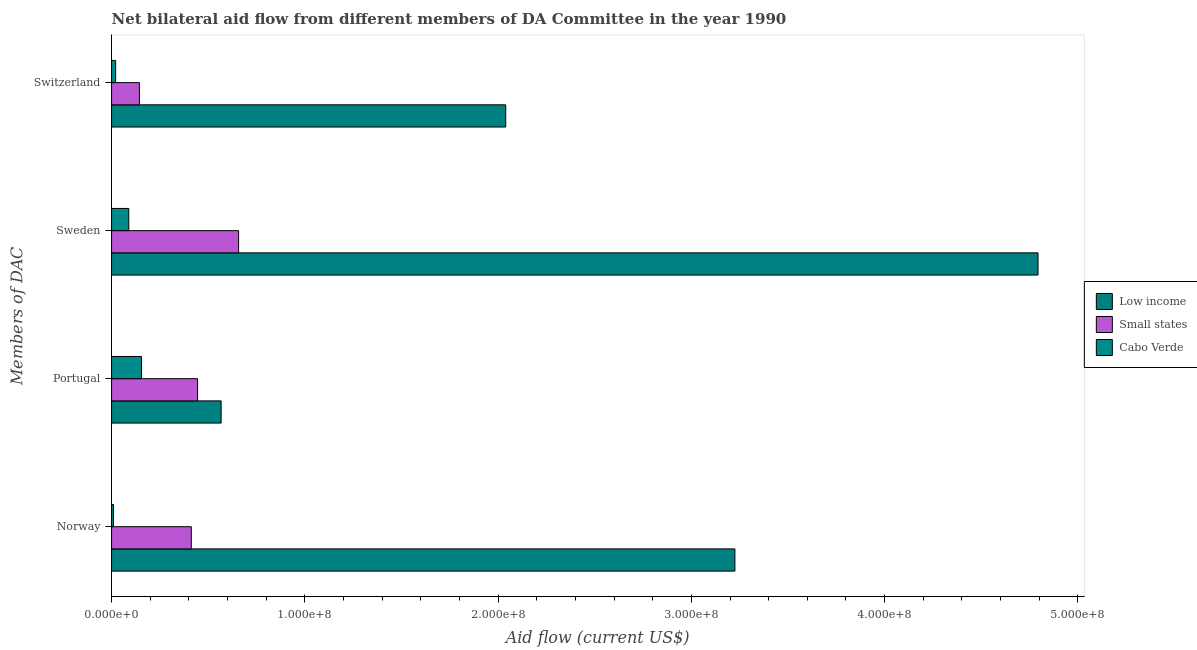Are the number of bars per tick equal to the number of legend labels?
Give a very brief answer. Yes. How many bars are there on the 1st tick from the top?
Keep it short and to the point. 3. How many bars are there on the 2nd tick from the bottom?
Ensure brevity in your answer.  3. What is the label of the 3rd group of bars from the top?
Your answer should be very brief. Portugal. What is the amount of aid given by norway in Low income?
Ensure brevity in your answer.  3.23e+08. Across all countries, what is the maximum amount of aid given by portugal?
Provide a short and direct response. 5.67e+07. Across all countries, what is the minimum amount of aid given by switzerland?
Offer a terse response. 2.11e+06. In which country was the amount of aid given by portugal maximum?
Offer a terse response. Low income. In which country was the amount of aid given by sweden minimum?
Your answer should be very brief. Cabo Verde. What is the total amount of aid given by portugal in the graph?
Offer a terse response. 1.17e+08. What is the difference between the amount of aid given by switzerland in Cabo Verde and that in Small states?
Keep it short and to the point. -1.23e+07. What is the difference between the amount of aid given by sweden in Low income and the amount of aid given by norway in Cabo Verde?
Your response must be concise. 4.78e+08. What is the average amount of aid given by norway per country?
Ensure brevity in your answer.  1.22e+08. What is the difference between the amount of aid given by portugal and amount of aid given by sweden in Low income?
Your answer should be compact. -4.23e+08. In how many countries, is the amount of aid given by norway greater than 140000000 US$?
Your answer should be very brief. 1. What is the ratio of the amount of aid given by switzerland in Cabo Verde to that in Low income?
Offer a very short reply. 0.01. Is the amount of aid given by switzerland in Low income less than that in Small states?
Your response must be concise. No. What is the difference between the highest and the second highest amount of aid given by norway?
Your answer should be compact. 2.81e+08. What is the difference between the highest and the lowest amount of aid given by switzerland?
Keep it short and to the point. 2.02e+08. In how many countries, is the amount of aid given by norway greater than the average amount of aid given by norway taken over all countries?
Provide a short and direct response. 1. Is the sum of the amount of aid given by sweden in Small states and Low income greater than the maximum amount of aid given by portugal across all countries?
Your response must be concise. Yes. Is it the case that in every country, the sum of the amount of aid given by portugal and amount of aid given by sweden is greater than the sum of amount of aid given by norway and amount of aid given by switzerland?
Offer a very short reply. No. What does the 1st bar from the top in Portugal represents?
Your answer should be compact. Cabo Verde. What does the 3rd bar from the bottom in Portugal represents?
Your answer should be compact. Cabo Verde. Is it the case that in every country, the sum of the amount of aid given by norway and amount of aid given by portugal is greater than the amount of aid given by sweden?
Offer a terse response. No. Are all the bars in the graph horizontal?
Offer a terse response. Yes. Does the graph contain any zero values?
Provide a short and direct response. No. Does the graph contain grids?
Give a very brief answer. No. How many legend labels are there?
Your answer should be compact. 3. How are the legend labels stacked?
Make the answer very short. Vertical. What is the title of the graph?
Offer a very short reply. Net bilateral aid flow from different members of DA Committee in the year 1990. What is the label or title of the X-axis?
Keep it short and to the point. Aid flow (current US$). What is the label or title of the Y-axis?
Your response must be concise. Members of DAC. What is the Aid flow (current US$) of Low income in Norway?
Keep it short and to the point. 3.23e+08. What is the Aid flow (current US$) of Small states in Norway?
Your answer should be compact. 4.13e+07. What is the Aid flow (current US$) in Cabo Verde in Norway?
Provide a succinct answer. 9.80e+05. What is the Aid flow (current US$) in Low income in Portugal?
Keep it short and to the point. 5.67e+07. What is the Aid flow (current US$) in Small states in Portugal?
Your response must be concise. 4.45e+07. What is the Aid flow (current US$) in Cabo Verde in Portugal?
Offer a very short reply. 1.55e+07. What is the Aid flow (current US$) in Low income in Sweden?
Ensure brevity in your answer.  4.79e+08. What is the Aid flow (current US$) of Small states in Sweden?
Keep it short and to the point. 6.57e+07. What is the Aid flow (current US$) of Cabo Verde in Sweden?
Offer a very short reply. 8.91e+06. What is the Aid flow (current US$) in Low income in Switzerland?
Make the answer very short. 2.04e+08. What is the Aid flow (current US$) in Small states in Switzerland?
Give a very brief answer. 1.44e+07. What is the Aid flow (current US$) of Cabo Verde in Switzerland?
Ensure brevity in your answer.  2.11e+06. Across all Members of DAC, what is the maximum Aid flow (current US$) in Low income?
Provide a succinct answer. 4.79e+08. Across all Members of DAC, what is the maximum Aid flow (current US$) in Small states?
Your response must be concise. 6.57e+07. Across all Members of DAC, what is the maximum Aid flow (current US$) in Cabo Verde?
Your answer should be very brief. 1.55e+07. Across all Members of DAC, what is the minimum Aid flow (current US$) of Low income?
Offer a very short reply. 5.67e+07. Across all Members of DAC, what is the minimum Aid flow (current US$) in Small states?
Keep it short and to the point. 1.44e+07. Across all Members of DAC, what is the minimum Aid flow (current US$) in Cabo Verde?
Your answer should be compact. 9.80e+05. What is the total Aid flow (current US$) in Low income in the graph?
Your answer should be compact. 1.06e+09. What is the total Aid flow (current US$) in Small states in the graph?
Make the answer very short. 1.66e+08. What is the total Aid flow (current US$) of Cabo Verde in the graph?
Your answer should be very brief. 2.75e+07. What is the difference between the Aid flow (current US$) of Low income in Norway and that in Portugal?
Your answer should be very brief. 2.66e+08. What is the difference between the Aid flow (current US$) of Small states in Norway and that in Portugal?
Offer a very short reply. -3.24e+06. What is the difference between the Aid flow (current US$) in Cabo Verde in Norway and that in Portugal?
Offer a terse response. -1.45e+07. What is the difference between the Aid flow (current US$) in Low income in Norway and that in Sweden?
Provide a short and direct response. -1.57e+08. What is the difference between the Aid flow (current US$) of Small states in Norway and that in Sweden?
Give a very brief answer. -2.45e+07. What is the difference between the Aid flow (current US$) in Cabo Verde in Norway and that in Sweden?
Give a very brief answer. -7.93e+06. What is the difference between the Aid flow (current US$) of Low income in Norway and that in Switzerland?
Provide a short and direct response. 1.19e+08. What is the difference between the Aid flow (current US$) of Small states in Norway and that in Switzerland?
Provide a succinct answer. 2.69e+07. What is the difference between the Aid flow (current US$) of Cabo Verde in Norway and that in Switzerland?
Keep it short and to the point. -1.13e+06. What is the difference between the Aid flow (current US$) in Low income in Portugal and that in Sweden?
Your answer should be compact. -4.23e+08. What is the difference between the Aid flow (current US$) of Small states in Portugal and that in Sweden?
Provide a short and direct response. -2.12e+07. What is the difference between the Aid flow (current US$) of Cabo Verde in Portugal and that in Sweden?
Provide a succinct answer. 6.59e+06. What is the difference between the Aid flow (current US$) of Low income in Portugal and that in Switzerland?
Provide a short and direct response. -1.47e+08. What is the difference between the Aid flow (current US$) in Small states in Portugal and that in Switzerland?
Offer a very short reply. 3.01e+07. What is the difference between the Aid flow (current US$) in Cabo Verde in Portugal and that in Switzerland?
Your answer should be compact. 1.34e+07. What is the difference between the Aid flow (current US$) in Low income in Sweden and that in Switzerland?
Offer a terse response. 2.75e+08. What is the difference between the Aid flow (current US$) in Small states in Sweden and that in Switzerland?
Give a very brief answer. 5.13e+07. What is the difference between the Aid flow (current US$) of Cabo Verde in Sweden and that in Switzerland?
Give a very brief answer. 6.80e+06. What is the difference between the Aid flow (current US$) of Low income in Norway and the Aid flow (current US$) of Small states in Portugal?
Offer a terse response. 2.78e+08. What is the difference between the Aid flow (current US$) in Low income in Norway and the Aid flow (current US$) in Cabo Verde in Portugal?
Make the answer very short. 3.07e+08. What is the difference between the Aid flow (current US$) in Small states in Norway and the Aid flow (current US$) in Cabo Verde in Portugal?
Your answer should be compact. 2.58e+07. What is the difference between the Aid flow (current US$) of Low income in Norway and the Aid flow (current US$) of Small states in Sweden?
Make the answer very short. 2.57e+08. What is the difference between the Aid flow (current US$) of Low income in Norway and the Aid flow (current US$) of Cabo Verde in Sweden?
Provide a succinct answer. 3.14e+08. What is the difference between the Aid flow (current US$) in Small states in Norway and the Aid flow (current US$) in Cabo Verde in Sweden?
Keep it short and to the point. 3.24e+07. What is the difference between the Aid flow (current US$) in Low income in Norway and the Aid flow (current US$) in Small states in Switzerland?
Make the answer very short. 3.08e+08. What is the difference between the Aid flow (current US$) of Low income in Norway and the Aid flow (current US$) of Cabo Verde in Switzerland?
Give a very brief answer. 3.20e+08. What is the difference between the Aid flow (current US$) of Small states in Norway and the Aid flow (current US$) of Cabo Verde in Switzerland?
Give a very brief answer. 3.92e+07. What is the difference between the Aid flow (current US$) of Low income in Portugal and the Aid flow (current US$) of Small states in Sweden?
Provide a succinct answer. -9.03e+06. What is the difference between the Aid flow (current US$) of Low income in Portugal and the Aid flow (current US$) of Cabo Verde in Sweden?
Offer a terse response. 4.78e+07. What is the difference between the Aid flow (current US$) in Small states in Portugal and the Aid flow (current US$) in Cabo Verde in Sweden?
Make the answer very short. 3.56e+07. What is the difference between the Aid flow (current US$) of Low income in Portugal and the Aid flow (current US$) of Small states in Switzerland?
Provide a short and direct response. 4.23e+07. What is the difference between the Aid flow (current US$) in Low income in Portugal and the Aid flow (current US$) in Cabo Verde in Switzerland?
Keep it short and to the point. 5.46e+07. What is the difference between the Aid flow (current US$) of Small states in Portugal and the Aid flow (current US$) of Cabo Verde in Switzerland?
Your response must be concise. 4.24e+07. What is the difference between the Aid flow (current US$) in Low income in Sweden and the Aid flow (current US$) in Small states in Switzerland?
Make the answer very short. 4.65e+08. What is the difference between the Aid flow (current US$) in Low income in Sweden and the Aid flow (current US$) in Cabo Verde in Switzerland?
Make the answer very short. 4.77e+08. What is the difference between the Aid flow (current US$) of Small states in Sweden and the Aid flow (current US$) of Cabo Verde in Switzerland?
Provide a short and direct response. 6.36e+07. What is the average Aid flow (current US$) in Low income per Members of DAC?
Your answer should be very brief. 2.66e+08. What is the average Aid flow (current US$) in Small states per Members of DAC?
Your answer should be very brief. 4.15e+07. What is the average Aid flow (current US$) of Cabo Verde per Members of DAC?
Provide a short and direct response. 6.88e+06. What is the difference between the Aid flow (current US$) in Low income and Aid flow (current US$) in Small states in Norway?
Ensure brevity in your answer.  2.81e+08. What is the difference between the Aid flow (current US$) in Low income and Aid flow (current US$) in Cabo Verde in Norway?
Your answer should be compact. 3.22e+08. What is the difference between the Aid flow (current US$) in Small states and Aid flow (current US$) in Cabo Verde in Norway?
Your answer should be compact. 4.03e+07. What is the difference between the Aid flow (current US$) of Low income and Aid flow (current US$) of Small states in Portugal?
Your answer should be very brief. 1.22e+07. What is the difference between the Aid flow (current US$) in Low income and Aid flow (current US$) in Cabo Verde in Portugal?
Offer a very short reply. 4.12e+07. What is the difference between the Aid flow (current US$) of Small states and Aid flow (current US$) of Cabo Verde in Portugal?
Your answer should be very brief. 2.90e+07. What is the difference between the Aid flow (current US$) of Low income and Aid flow (current US$) of Small states in Sweden?
Your answer should be compact. 4.14e+08. What is the difference between the Aid flow (current US$) of Low income and Aid flow (current US$) of Cabo Verde in Sweden?
Provide a succinct answer. 4.70e+08. What is the difference between the Aid flow (current US$) in Small states and Aid flow (current US$) in Cabo Verde in Sweden?
Provide a succinct answer. 5.68e+07. What is the difference between the Aid flow (current US$) of Low income and Aid flow (current US$) of Small states in Switzerland?
Offer a very short reply. 1.90e+08. What is the difference between the Aid flow (current US$) in Low income and Aid flow (current US$) in Cabo Verde in Switzerland?
Your answer should be compact. 2.02e+08. What is the difference between the Aid flow (current US$) in Small states and Aid flow (current US$) in Cabo Verde in Switzerland?
Your answer should be very brief. 1.23e+07. What is the ratio of the Aid flow (current US$) of Low income in Norway to that in Portugal?
Make the answer very short. 5.69. What is the ratio of the Aid flow (current US$) of Small states in Norway to that in Portugal?
Your response must be concise. 0.93. What is the ratio of the Aid flow (current US$) in Cabo Verde in Norway to that in Portugal?
Your answer should be compact. 0.06. What is the ratio of the Aid flow (current US$) of Low income in Norway to that in Sweden?
Your answer should be very brief. 0.67. What is the ratio of the Aid flow (current US$) of Small states in Norway to that in Sweden?
Your answer should be compact. 0.63. What is the ratio of the Aid flow (current US$) of Cabo Verde in Norway to that in Sweden?
Make the answer very short. 0.11. What is the ratio of the Aid flow (current US$) of Low income in Norway to that in Switzerland?
Provide a succinct answer. 1.58. What is the ratio of the Aid flow (current US$) in Small states in Norway to that in Switzerland?
Provide a short and direct response. 2.87. What is the ratio of the Aid flow (current US$) of Cabo Verde in Norway to that in Switzerland?
Your response must be concise. 0.46. What is the ratio of the Aid flow (current US$) in Low income in Portugal to that in Sweden?
Provide a succinct answer. 0.12. What is the ratio of the Aid flow (current US$) of Small states in Portugal to that in Sweden?
Your answer should be very brief. 0.68. What is the ratio of the Aid flow (current US$) of Cabo Verde in Portugal to that in Sweden?
Offer a very short reply. 1.74. What is the ratio of the Aid flow (current US$) in Low income in Portugal to that in Switzerland?
Ensure brevity in your answer.  0.28. What is the ratio of the Aid flow (current US$) of Small states in Portugal to that in Switzerland?
Keep it short and to the point. 3.09. What is the ratio of the Aid flow (current US$) in Cabo Verde in Portugal to that in Switzerland?
Provide a short and direct response. 7.35. What is the ratio of the Aid flow (current US$) in Low income in Sweden to that in Switzerland?
Give a very brief answer. 2.35. What is the ratio of the Aid flow (current US$) in Small states in Sweden to that in Switzerland?
Offer a very short reply. 4.56. What is the ratio of the Aid flow (current US$) in Cabo Verde in Sweden to that in Switzerland?
Your response must be concise. 4.22. What is the difference between the highest and the second highest Aid flow (current US$) of Low income?
Offer a very short reply. 1.57e+08. What is the difference between the highest and the second highest Aid flow (current US$) of Small states?
Give a very brief answer. 2.12e+07. What is the difference between the highest and the second highest Aid flow (current US$) of Cabo Verde?
Your answer should be very brief. 6.59e+06. What is the difference between the highest and the lowest Aid flow (current US$) of Low income?
Your answer should be very brief. 4.23e+08. What is the difference between the highest and the lowest Aid flow (current US$) in Small states?
Provide a short and direct response. 5.13e+07. What is the difference between the highest and the lowest Aid flow (current US$) in Cabo Verde?
Give a very brief answer. 1.45e+07. 